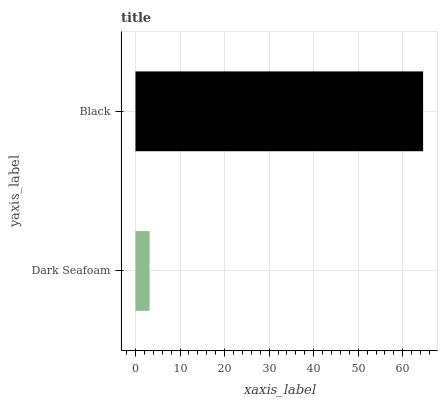Is Dark Seafoam the minimum?
Answer yes or no. Yes. Is Black the maximum?
Answer yes or no. Yes. Is Black the minimum?
Answer yes or no. No. Is Black greater than Dark Seafoam?
Answer yes or no. Yes. Is Dark Seafoam less than Black?
Answer yes or no. Yes. Is Dark Seafoam greater than Black?
Answer yes or no. No. Is Black less than Dark Seafoam?
Answer yes or no. No. Is Black the high median?
Answer yes or no. Yes. Is Dark Seafoam the low median?
Answer yes or no. Yes. Is Dark Seafoam the high median?
Answer yes or no. No. Is Black the low median?
Answer yes or no. No. 